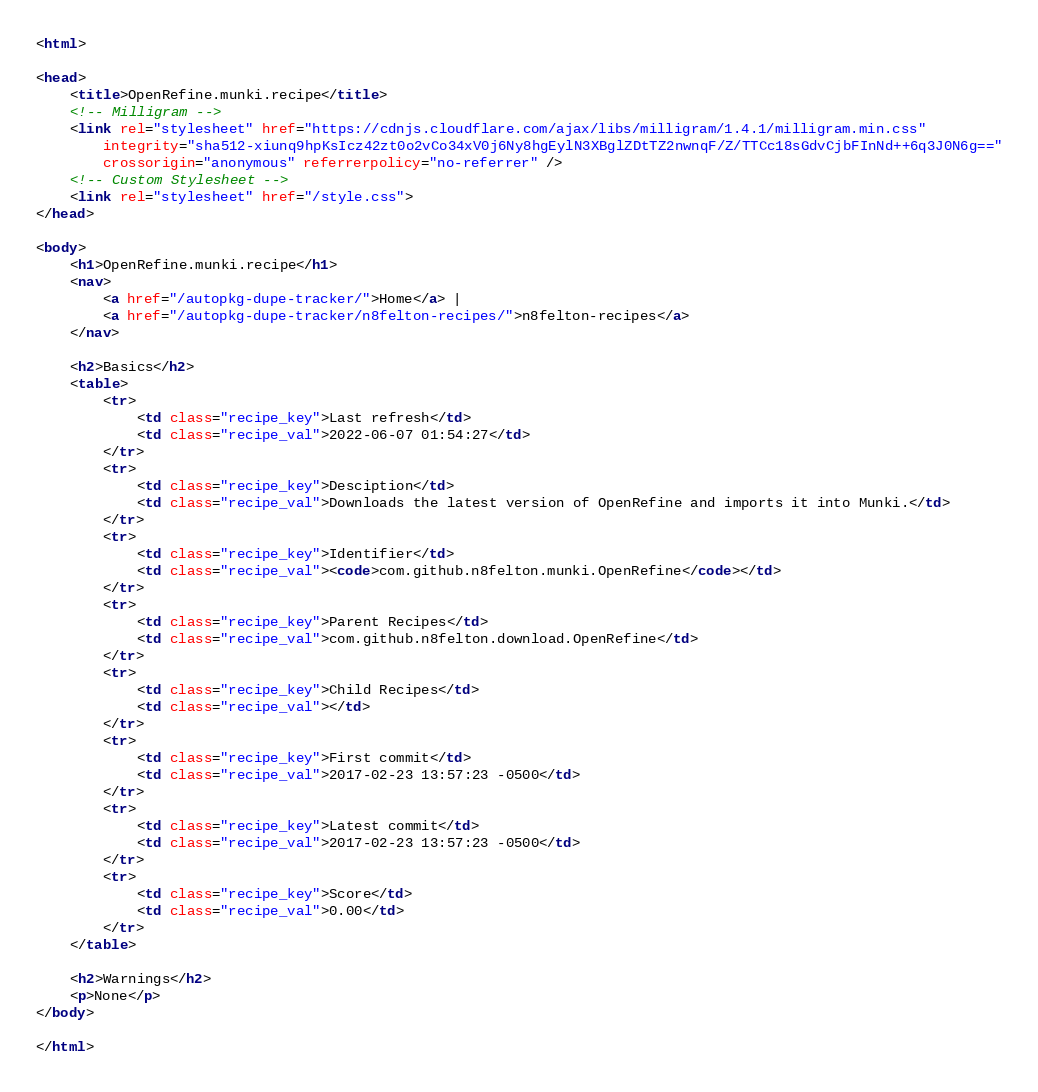<code> <loc_0><loc_0><loc_500><loc_500><_HTML_><html>

<head>
    <title>OpenRefine.munki.recipe</title>
    <!-- Milligram -->
    <link rel="stylesheet" href="https://cdnjs.cloudflare.com/ajax/libs/milligram/1.4.1/milligram.min.css"
        integrity="sha512-xiunq9hpKsIcz42zt0o2vCo34xV0j6Ny8hgEylN3XBglZDtTZ2nwnqF/Z/TTCc18sGdvCjbFInNd++6q3J0N6g=="
        crossorigin="anonymous" referrerpolicy="no-referrer" />
    <!-- Custom Stylesheet -->
    <link rel="stylesheet" href="/style.css">
</head>

<body>
    <h1>OpenRefine.munki.recipe</h1>
    <nav>
        <a href="/autopkg-dupe-tracker/">Home</a> |
        <a href="/autopkg-dupe-tracker/n8felton-recipes/">n8felton-recipes</a>
    </nav>

    <h2>Basics</h2>
    <table>
        <tr>
            <td class="recipe_key">Last refresh</td>
            <td class="recipe_val">2022-06-07 01:54:27</td>
        </tr>
        <tr>
            <td class="recipe_key">Desciption</td>
            <td class="recipe_val">Downloads the latest version of OpenRefine and imports it into Munki.</td>
        </tr>
        <tr>
            <td class="recipe_key">Identifier</td>
            <td class="recipe_val"><code>com.github.n8felton.munki.OpenRefine</code></td>
        </tr>
        <tr>
            <td class="recipe_key">Parent Recipes</td>
            <td class="recipe_val">com.github.n8felton.download.OpenRefine</td>
        </tr>
        <tr>
            <td class="recipe_key">Child Recipes</td>
            <td class="recipe_val"></td>
        </tr>
        <tr>
            <td class="recipe_key">First commit</td>
            <td class="recipe_val">2017-02-23 13:57:23 -0500</td>
        </tr>
        <tr>
            <td class="recipe_key">Latest commit</td>
            <td class="recipe_val">2017-02-23 13:57:23 -0500</td>
        </tr>
        <tr>
            <td class="recipe_key">Score</td>
            <td class="recipe_val">0.00</td>
        </tr>
    </table>

    <h2>Warnings</h2>
    <p>None</p>
</body>

</html>
</code> 